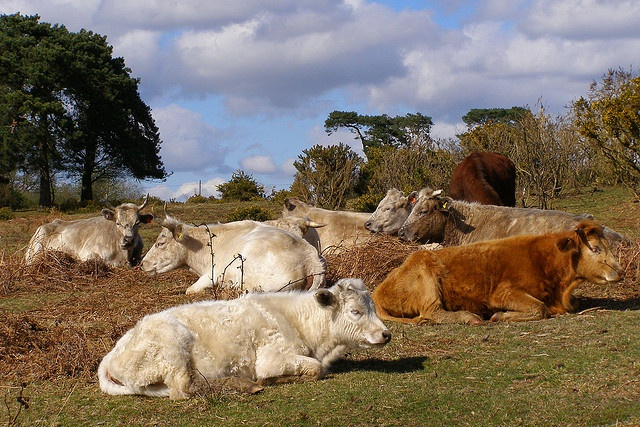Describe the objects in this image and their specific colors. I can see cow in darkgray, tan, and beige tones, cow in darkgray, maroon, brown, and black tones, cow in darkgray, beige, and tan tones, cow in darkgray, gray, maroon, black, and tan tones, and cow in darkgray, tan, gray, and black tones in this image. 